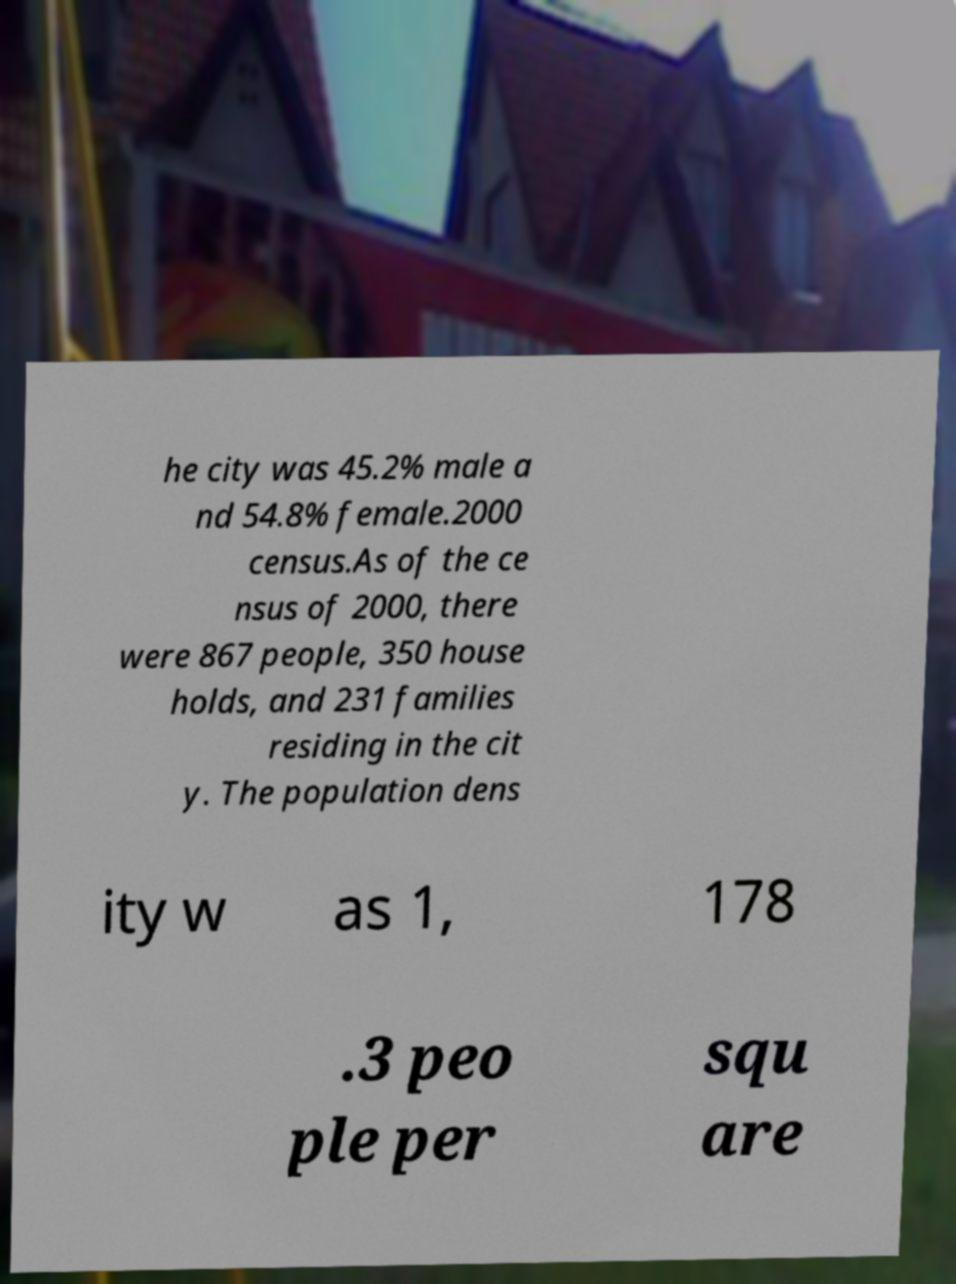There's text embedded in this image that I need extracted. Can you transcribe it verbatim? he city was 45.2% male a nd 54.8% female.2000 census.As of the ce nsus of 2000, there were 867 people, 350 house holds, and 231 families residing in the cit y. The population dens ity w as 1, 178 .3 peo ple per squ are 